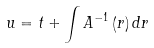Convert formula to latex. <formula><loc_0><loc_0><loc_500><loc_500>u = t + \int A ^ { - 1 } \left ( r \right ) d r</formula> 